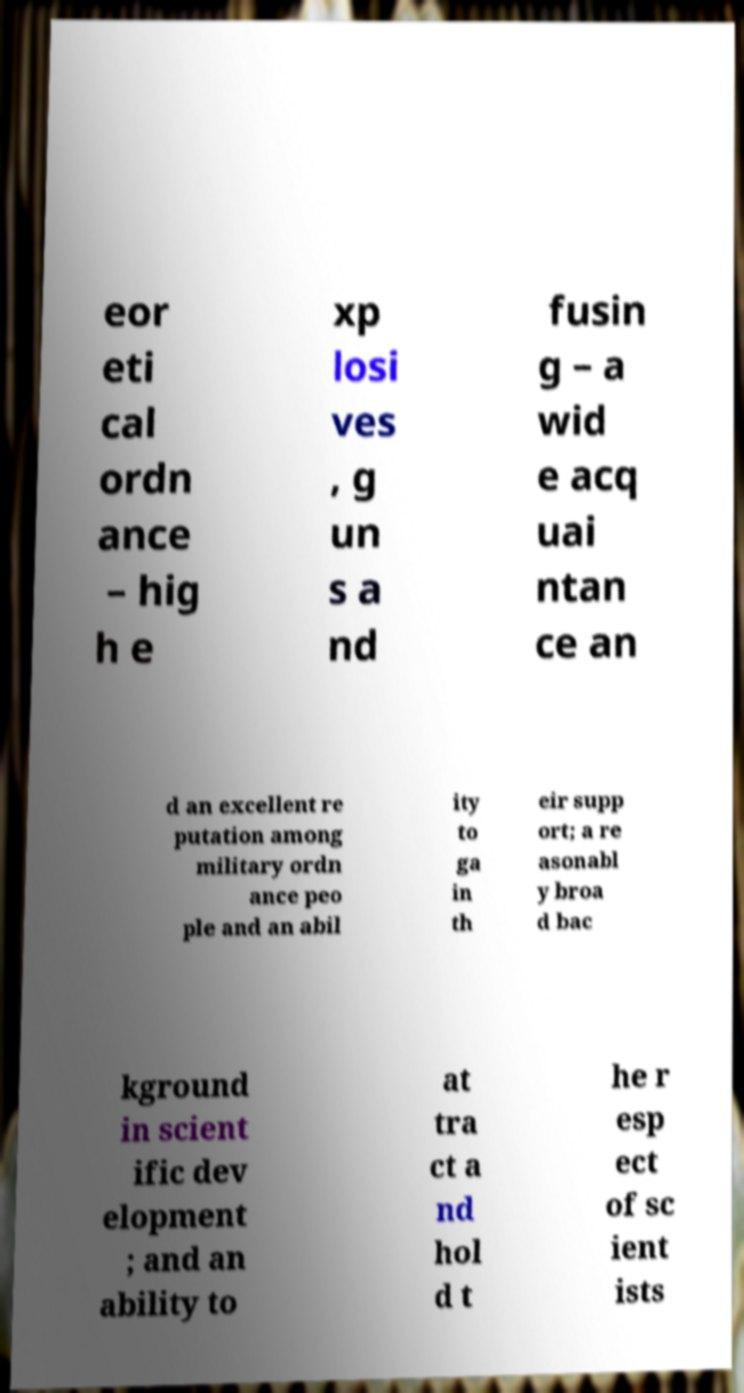For documentation purposes, I need the text within this image transcribed. Could you provide that? eor eti cal ordn ance – hig h e xp losi ves , g un s a nd fusin g – a wid e acq uai ntan ce an d an excellent re putation among military ordn ance peo ple and an abil ity to ga in th eir supp ort; a re asonabl y broa d bac kground in scient ific dev elopment ; and an ability to at tra ct a nd hol d t he r esp ect of sc ient ists 